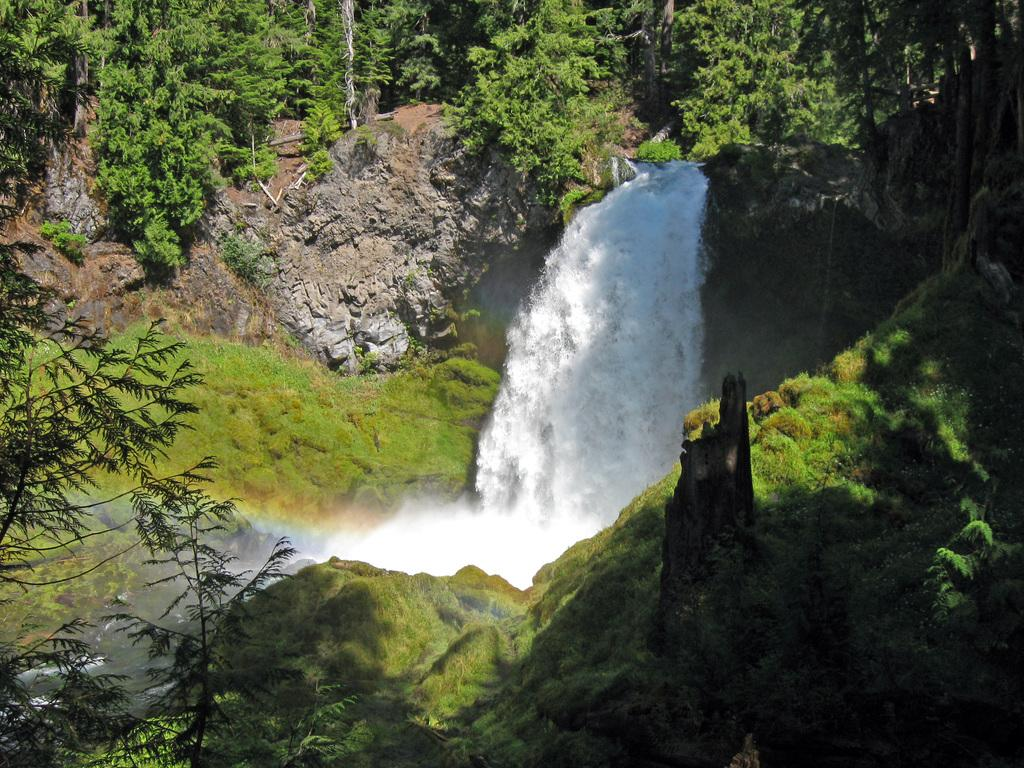What natural feature is the main subject of the image? There is a waterfall in the image. What other elements can be seen in the image? There are rocks and trees in the image. Can you describe the vegetation in the image? There are trees in the image. What is the texture of the rocks in the image? There is grass on the rocks in the image. What type of van can be seen parked near the waterfall in the image? There is no van present in the image; it only features a waterfall, rocks, trees, and grass on the rocks. 